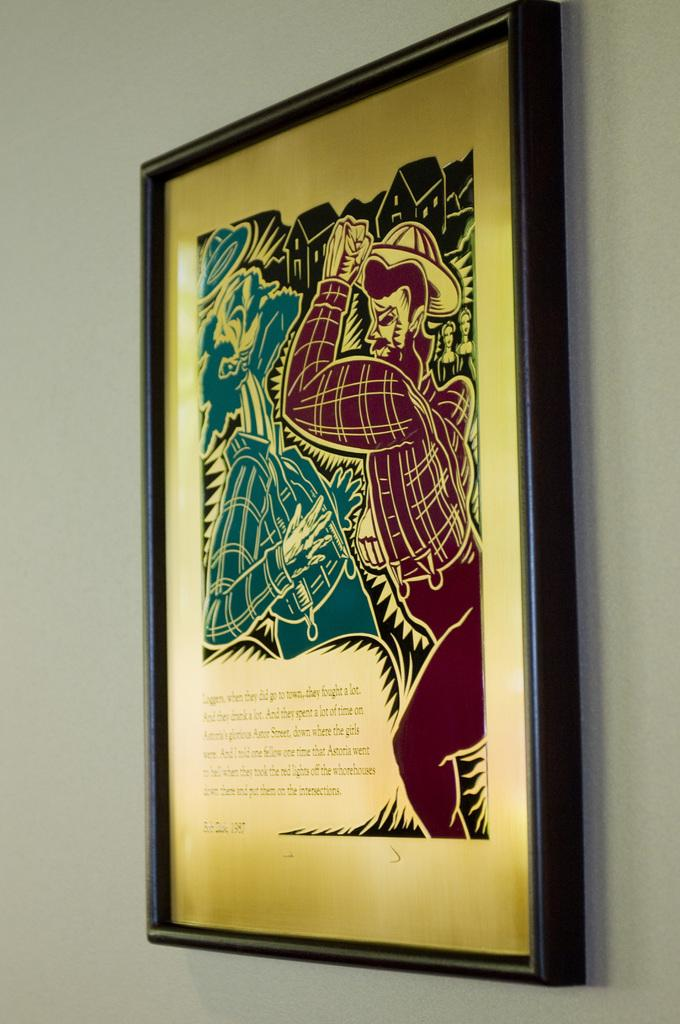What is present on the wall in the image? There is a photo frame attached to the wall in the image. What is inside the photo frame? The photo frame contains graphical images and text. Can you describe the content of the photo frame? The photo frame contains graphical images and text. Can you tell me how many donkeys are visible in the photo frame? There are no donkeys visible in the photo frame; it contains graphical images and text. 